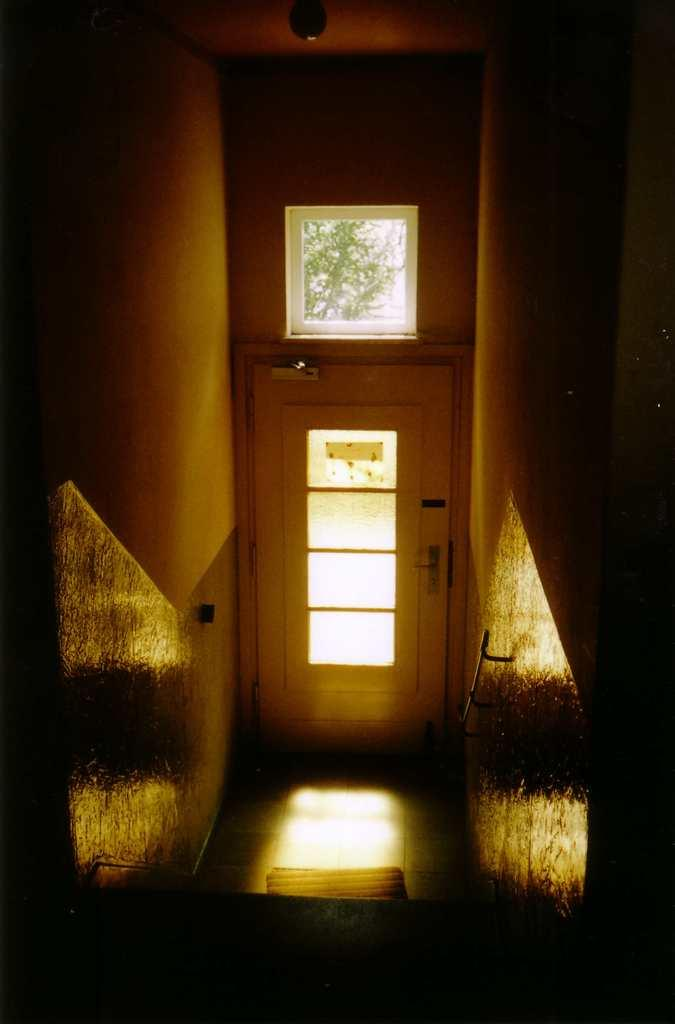What type of structure is present in the image? There are stairs and a door in the image. What can be seen above the door in the image? There is a ventilator in the image. What is visible through the ventilator? Trees are visible through the ventilator. Can you see an umbrella being used to water the trees through the ventilator in the image? There is no umbrella or hose visible in the image, and therefore no such activity can be observed. 